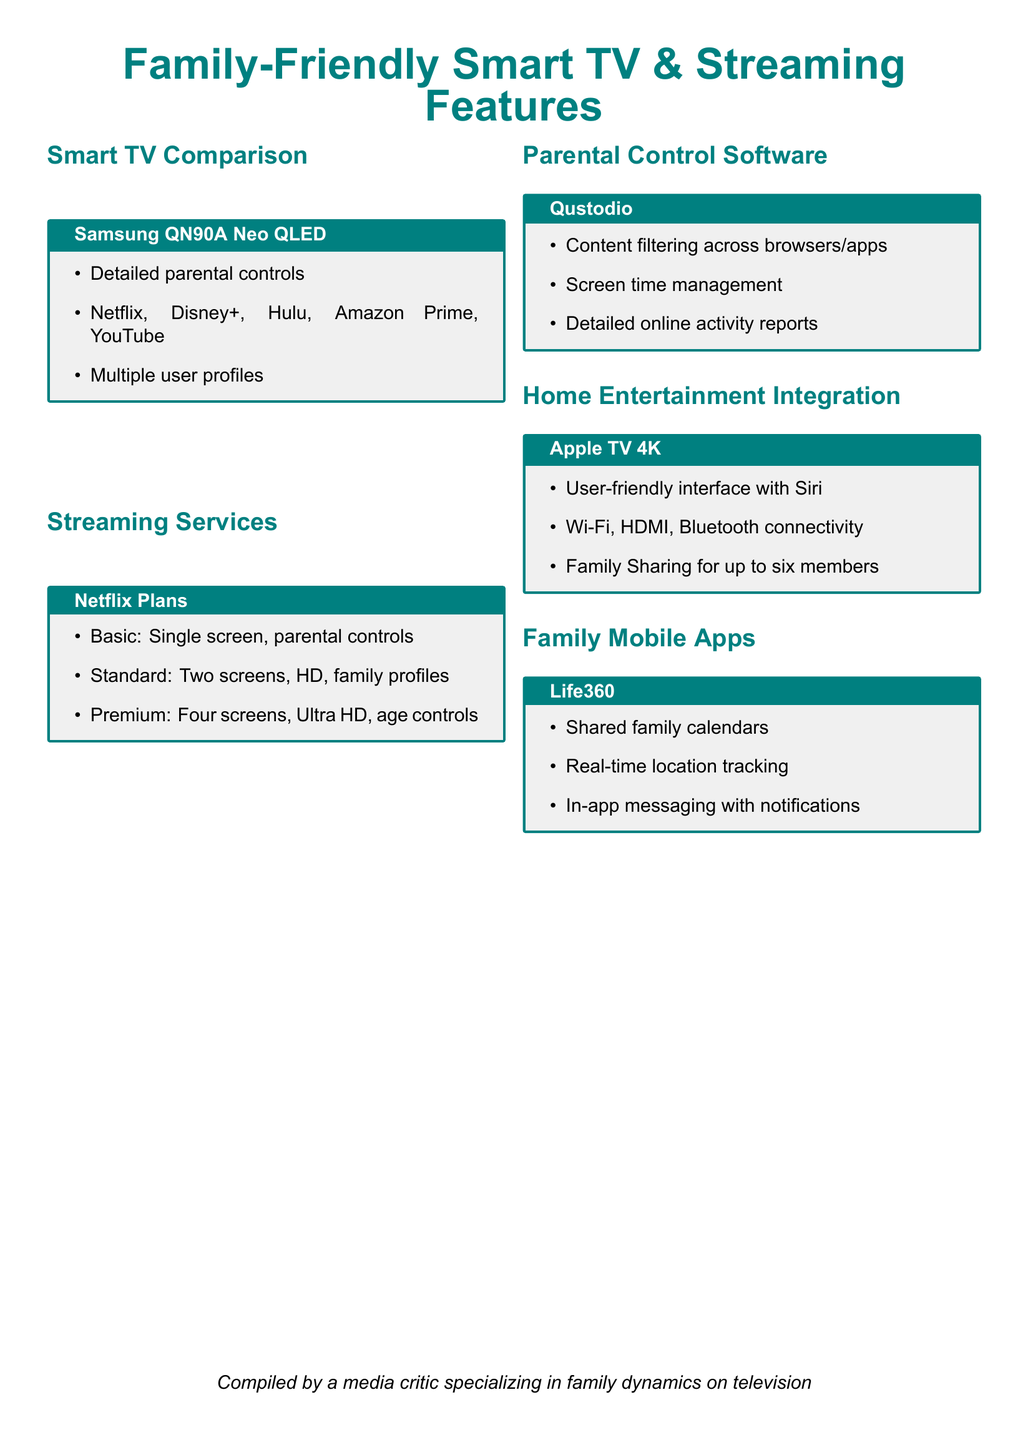What TV model offers detailed parental controls? The document specifies that the Samsung QN90A Neo QLED has detailed parental controls.
Answer: Samsung QN90A Neo QLED Which streaming service is compatible with the Samsung QN90A? The document lists Netflix, Disney+, Hulu, Amazon Prime, and YouTube as compatible streaming services for the Samsung QN90A.
Answer: Netflix, Disney+, Hulu, Amazon Prime, YouTube How many screens does the Premium Netflix plan support? According to the document, the Premium Netflix plan supports four screens.
Answer: Four screens What capability does Qustodio provide for screen time? The document states that Qustodio includes screen time management capabilities.
Answer: Screen time management How many family members can use Family Sharing on Apple TV 4K? The document mentions that Family Sharing allows up to six members.
Answer: Six members What is a feature of the Life360 mobile app? The document highlights that Life360 has shared family calendars as a feature.
Answer: Shared family calendars Which streaming service plan offers family profiles? The document specifies that the Standard plan of Netflix offers family profiles.
Answer: Standard What type of integration does Apple TV 4K emphasize? The document notes that Apple TV 4K emphasizes user-friendly interface with Siri for integration.
Answer: User-friendly interface with Siri What type of content does Qustodio filter? The document indicates that Qustodio filters content across browsers/apps.
Answer: Content filtering across browsers/apps 